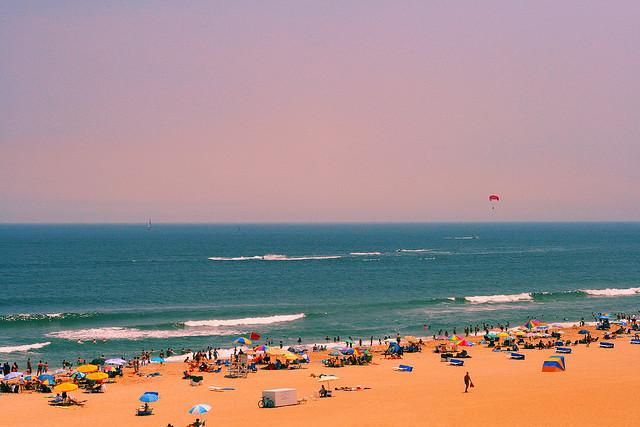Are there any umbrellas open?
Answer briefly. Yes. What is off in the distance in the sky?
Keep it brief. Kite. Is it a beautiful day?
Keep it brief. Yes. 